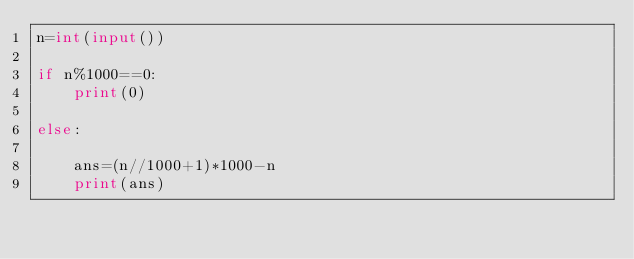Convert code to text. <code><loc_0><loc_0><loc_500><loc_500><_Python_>n=int(input())

if n%1000==0:
    print(0)
    
else:
    
    ans=(n//1000+1)*1000-n
    print(ans)
</code> 